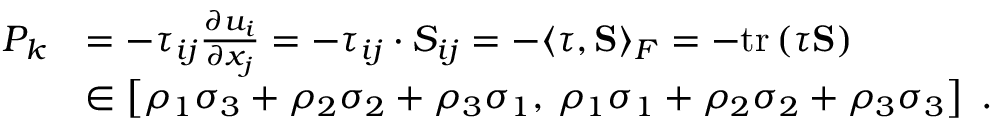<formula> <loc_0><loc_0><loc_500><loc_500>\begin{array} { r l } { P _ { k } } & { = - \tau _ { i j } \frac { \partial u _ { i } } { \partial x _ { j } } = - \tau _ { i j } \cdot S _ { i j } = - \langle \tau , S \rangle _ { F } = - t r \left ( \tau S \right ) } \\ & { \in \left [ \rho _ { 1 } \sigma _ { 3 } + \rho _ { 2 } \sigma _ { 2 } + \rho _ { 3 } \sigma _ { 1 } , \, \rho _ { 1 } \sigma _ { 1 } + \rho _ { 2 } \sigma _ { 2 } + \rho _ { 3 } \sigma _ { 3 } \right ] \ . } \end{array}</formula> 